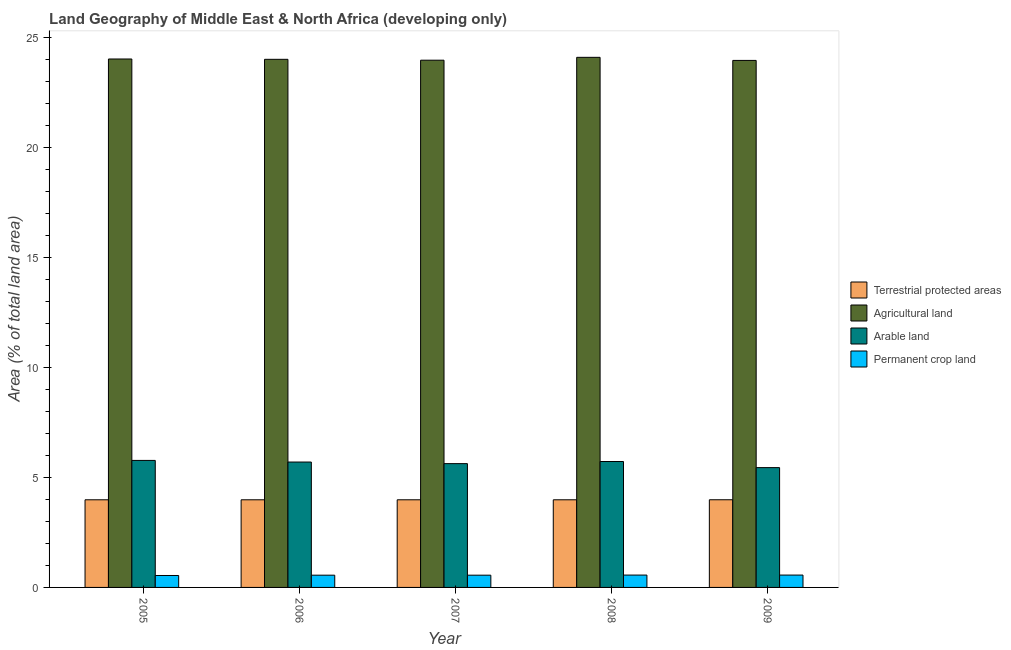How many different coloured bars are there?
Offer a very short reply. 4. What is the percentage of area under arable land in 2006?
Your answer should be compact. 5.7. Across all years, what is the maximum percentage of land under terrestrial protection?
Provide a succinct answer. 3.98. Across all years, what is the minimum percentage of area under permanent crop land?
Offer a very short reply. 0.54. In which year was the percentage of area under agricultural land minimum?
Ensure brevity in your answer.  2009. What is the total percentage of land under terrestrial protection in the graph?
Provide a succinct answer. 19.92. What is the difference between the percentage of area under permanent crop land in 2006 and that in 2008?
Make the answer very short. -0.01. What is the difference between the percentage of area under arable land in 2008 and the percentage of land under terrestrial protection in 2009?
Offer a terse response. 0.28. What is the average percentage of area under permanent crop land per year?
Your answer should be compact. 0.56. In the year 2006, what is the difference between the percentage of area under agricultural land and percentage of area under permanent crop land?
Ensure brevity in your answer.  0. In how many years, is the percentage of area under arable land greater than 20 %?
Ensure brevity in your answer.  0. What is the ratio of the percentage of area under arable land in 2006 to that in 2009?
Your answer should be compact. 1.05. Is the percentage of area under permanent crop land in 2005 less than that in 2009?
Your response must be concise. Yes. What is the difference between the highest and the second highest percentage of area under agricultural land?
Your answer should be compact. 0.08. What is the difference between the highest and the lowest percentage of area under agricultural land?
Provide a succinct answer. 0.14. Is the sum of the percentage of area under arable land in 2006 and 2008 greater than the maximum percentage of area under permanent crop land across all years?
Offer a very short reply. Yes. Is it the case that in every year, the sum of the percentage of area under agricultural land and percentage of land under terrestrial protection is greater than the sum of percentage of area under permanent crop land and percentage of area under arable land?
Your answer should be very brief. Yes. What does the 4th bar from the left in 2006 represents?
Your answer should be compact. Permanent crop land. What does the 1st bar from the right in 2007 represents?
Provide a short and direct response. Permanent crop land. Is it the case that in every year, the sum of the percentage of land under terrestrial protection and percentage of area under agricultural land is greater than the percentage of area under arable land?
Keep it short and to the point. Yes. What is the difference between two consecutive major ticks on the Y-axis?
Give a very brief answer. 5. Are the values on the major ticks of Y-axis written in scientific E-notation?
Your answer should be very brief. No. Does the graph contain any zero values?
Give a very brief answer. No. Does the graph contain grids?
Offer a terse response. No. How are the legend labels stacked?
Ensure brevity in your answer.  Vertical. What is the title of the graph?
Keep it short and to the point. Land Geography of Middle East & North Africa (developing only). Does "Denmark" appear as one of the legend labels in the graph?
Give a very brief answer. No. What is the label or title of the X-axis?
Give a very brief answer. Year. What is the label or title of the Y-axis?
Make the answer very short. Area (% of total land area). What is the Area (% of total land area) of Terrestrial protected areas in 2005?
Your answer should be compact. 3.98. What is the Area (% of total land area) in Agricultural land in 2005?
Give a very brief answer. 24.02. What is the Area (% of total land area) in Arable land in 2005?
Your answer should be compact. 5.77. What is the Area (% of total land area) in Permanent crop land in 2005?
Ensure brevity in your answer.  0.54. What is the Area (% of total land area) of Terrestrial protected areas in 2006?
Keep it short and to the point. 3.98. What is the Area (% of total land area) in Agricultural land in 2006?
Your response must be concise. 24.01. What is the Area (% of total land area) of Arable land in 2006?
Offer a terse response. 5.7. What is the Area (% of total land area) in Permanent crop land in 2006?
Your answer should be compact. 0.56. What is the Area (% of total land area) of Terrestrial protected areas in 2007?
Your answer should be compact. 3.98. What is the Area (% of total land area) of Agricultural land in 2007?
Provide a succinct answer. 23.97. What is the Area (% of total land area) in Arable land in 2007?
Your answer should be compact. 5.63. What is the Area (% of total land area) in Permanent crop land in 2007?
Your response must be concise. 0.56. What is the Area (% of total land area) of Terrestrial protected areas in 2008?
Ensure brevity in your answer.  3.98. What is the Area (% of total land area) in Agricultural land in 2008?
Offer a terse response. 24.1. What is the Area (% of total land area) of Arable land in 2008?
Make the answer very short. 5.72. What is the Area (% of total land area) in Permanent crop land in 2008?
Your answer should be very brief. 0.56. What is the Area (% of total land area) of Terrestrial protected areas in 2009?
Provide a succinct answer. 3.98. What is the Area (% of total land area) of Agricultural land in 2009?
Give a very brief answer. 23.96. What is the Area (% of total land area) in Arable land in 2009?
Give a very brief answer. 5.45. What is the Area (% of total land area) of Permanent crop land in 2009?
Make the answer very short. 0.56. Across all years, what is the maximum Area (% of total land area) of Terrestrial protected areas?
Provide a short and direct response. 3.98. Across all years, what is the maximum Area (% of total land area) in Agricultural land?
Offer a very short reply. 24.1. Across all years, what is the maximum Area (% of total land area) of Arable land?
Your response must be concise. 5.77. Across all years, what is the maximum Area (% of total land area) of Permanent crop land?
Provide a short and direct response. 0.56. Across all years, what is the minimum Area (% of total land area) of Terrestrial protected areas?
Your response must be concise. 3.98. Across all years, what is the minimum Area (% of total land area) of Agricultural land?
Make the answer very short. 23.96. Across all years, what is the minimum Area (% of total land area) in Arable land?
Offer a very short reply. 5.45. Across all years, what is the minimum Area (% of total land area) in Permanent crop land?
Offer a terse response. 0.54. What is the total Area (% of total land area) of Terrestrial protected areas in the graph?
Your response must be concise. 19.92. What is the total Area (% of total land area) of Agricultural land in the graph?
Provide a succinct answer. 120.04. What is the total Area (% of total land area) of Arable land in the graph?
Keep it short and to the point. 28.27. What is the total Area (% of total land area) in Permanent crop land in the graph?
Ensure brevity in your answer.  2.78. What is the difference between the Area (% of total land area) of Agricultural land in 2005 and that in 2006?
Your answer should be very brief. 0.02. What is the difference between the Area (% of total land area) in Arable land in 2005 and that in 2006?
Provide a short and direct response. 0.07. What is the difference between the Area (% of total land area) in Permanent crop land in 2005 and that in 2006?
Ensure brevity in your answer.  -0.01. What is the difference between the Area (% of total land area) of Terrestrial protected areas in 2005 and that in 2007?
Your response must be concise. 0. What is the difference between the Area (% of total land area) of Agricultural land in 2005 and that in 2007?
Provide a succinct answer. 0.06. What is the difference between the Area (% of total land area) in Arable land in 2005 and that in 2007?
Keep it short and to the point. 0.15. What is the difference between the Area (% of total land area) of Permanent crop land in 2005 and that in 2007?
Offer a very short reply. -0.01. What is the difference between the Area (% of total land area) of Agricultural land in 2005 and that in 2008?
Your answer should be very brief. -0.08. What is the difference between the Area (% of total land area) in Arable land in 2005 and that in 2008?
Offer a terse response. 0.05. What is the difference between the Area (% of total land area) in Permanent crop land in 2005 and that in 2008?
Make the answer very short. -0.02. What is the difference between the Area (% of total land area) of Terrestrial protected areas in 2005 and that in 2009?
Provide a short and direct response. -0. What is the difference between the Area (% of total land area) in Agricultural land in 2005 and that in 2009?
Offer a very short reply. 0.07. What is the difference between the Area (% of total land area) of Arable land in 2005 and that in 2009?
Keep it short and to the point. 0.33. What is the difference between the Area (% of total land area) of Permanent crop land in 2005 and that in 2009?
Provide a short and direct response. -0.02. What is the difference between the Area (% of total land area) in Agricultural land in 2006 and that in 2007?
Ensure brevity in your answer.  0.04. What is the difference between the Area (% of total land area) of Arable land in 2006 and that in 2007?
Your response must be concise. 0.07. What is the difference between the Area (% of total land area) in Permanent crop land in 2006 and that in 2007?
Offer a terse response. -0. What is the difference between the Area (% of total land area) of Terrestrial protected areas in 2006 and that in 2008?
Your answer should be compact. 0. What is the difference between the Area (% of total land area) in Agricultural land in 2006 and that in 2008?
Your response must be concise. -0.09. What is the difference between the Area (% of total land area) of Arable land in 2006 and that in 2008?
Offer a terse response. -0.02. What is the difference between the Area (% of total land area) in Permanent crop land in 2006 and that in 2008?
Your answer should be very brief. -0.01. What is the difference between the Area (% of total land area) in Terrestrial protected areas in 2006 and that in 2009?
Provide a succinct answer. -0. What is the difference between the Area (% of total land area) of Agricultural land in 2006 and that in 2009?
Provide a short and direct response. 0.05. What is the difference between the Area (% of total land area) in Arable land in 2006 and that in 2009?
Your response must be concise. 0.25. What is the difference between the Area (% of total land area) of Permanent crop land in 2006 and that in 2009?
Make the answer very short. -0.01. What is the difference between the Area (% of total land area) in Terrestrial protected areas in 2007 and that in 2008?
Keep it short and to the point. 0. What is the difference between the Area (% of total land area) in Agricultural land in 2007 and that in 2008?
Make the answer very short. -0.13. What is the difference between the Area (% of total land area) of Arable land in 2007 and that in 2008?
Your response must be concise. -0.1. What is the difference between the Area (% of total land area) in Permanent crop land in 2007 and that in 2008?
Offer a very short reply. -0. What is the difference between the Area (% of total land area) in Terrestrial protected areas in 2007 and that in 2009?
Your response must be concise. -0. What is the difference between the Area (% of total land area) of Agricultural land in 2007 and that in 2009?
Make the answer very short. 0.01. What is the difference between the Area (% of total land area) of Arable land in 2007 and that in 2009?
Give a very brief answer. 0.18. What is the difference between the Area (% of total land area) of Permanent crop land in 2007 and that in 2009?
Your answer should be compact. -0.01. What is the difference between the Area (% of total land area) in Terrestrial protected areas in 2008 and that in 2009?
Give a very brief answer. -0. What is the difference between the Area (% of total land area) in Agricultural land in 2008 and that in 2009?
Make the answer very short. 0.14. What is the difference between the Area (% of total land area) in Arable land in 2008 and that in 2009?
Provide a short and direct response. 0.28. What is the difference between the Area (% of total land area) of Permanent crop land in 2008 and that in 2009?
Provide a succinct answer. -0. What is the difference between the Area (% of total land area) of Terrestrial protected areas in 2005 and the Area (% of total land area) of Agricultural land in 2006?
Offer a very short reply. -20.02. What is the difference between the Area (% of total land area) of Terrestrial protected areas in 2005 and the Area (% of total land area) of Arable land in 2006?
Offer a very short reply. -1.72. What is the difference between the Area (% of total land area) in Terrestrial protected areas in 2005 and the Area (% of total land area) in Permanent crop land in 2006?
Provide a short and direct response. 3.43. What is the difference between the Area (% of total land area) in Agricultural land in 2005 and the Area (% of total land area) in Arable land in 2006?
Make the answer very short. 18.32. What is the difference between the Area (% of total land area) in Agricultural land in 2005 and the Area (% of total land area) in Permanent crop land in 2006?
Your answer should be very brief. 23.46. What is the difference between the Area (% of total land area) in Arable land in 2005 and the Area (% of total land area) in Permanent crop land in 2006?
Make the answer very short. 5.22. What is the difference between the Area (% of total land area) in Terrestrial protected areas in 2005 and the Area (% of total land area) in Agricultural land in 2007?
Provide a short and direct response. -19.98. What is the difference between the Area (% of total land area) in Terrestrial protected areas in 2005 and the Area (% of total land area) in Arable land in 2007?
Your answer should be compact. -1.64. What is the difference between the Area (% of total land area) in Terrestrial protected areas in 2005 and the Area (% of total land area) in Permanent crop land in 2007?
Give a very brief answer. 3.43. What is the difference between the Area (% of total land area) of Agricultural land in 2005 and the Area (% of total land area) of Arable land in 2007?
Keep it short and to the point. 18.39. What is the difference between the Area (% of total land area) in Agricultural land in 2005 and the Area (% of total land area) in Permanent crop land in 2007?
Provide a succinct answer. 23.46. What is the difference between the Area (% of total land area) in Arable land in 2005 and the Area (% of total land area) in Permanent crop land in 2007?
Offer a terse response. 5.22. What is the difference between the Area (% of total land area) in Terrestrial protected areas in 2005 and the Area (% of total land area) in Agricultural land in 2008?
Ensure brevity in your answer.  -20.11. What is the difference between the Area (% of total land area) of Terrestrial protected areas in 2005 and the Area (% of total land area) of Arable land in 2008?
Your answer should be very brief. -1.74. What is the difference between the Area (% of total land area) of Terrestrial protected areas in 2005 and the Area (% of total land area) of Permanent crop land in 2008?
Make the answer very short. 3.42. What is the difference between the Area (% of total land area) in Agricultural land in 2005 and the Area (% of total land area) in Arable land in 2008?
Keep it short and to the point. 18.3. What is the difference between the Area (% of total land area) of Agricultural land in 2005 and the Area (% of total land area) of Permanent crop land in 2008?
Provide a short and direct response. 23.46. What is the difference between the Area (% of total land area) of Arable land in 2005 and the Area (% of total land area) of Permanent crop land in 2008?
Keep it short and to the point. 5.21. What is the difference between the Area (% of total land area) in Terrestrial protected areas in 2005 and the Area (% of total land area) in Agricultural land in 2009?
Provide a short and direct response. -19.97. What is the difference between the Area (% of total land area) of Terrestrial protected areas in 2005 and the Area (% of total land area) of Arable land in 2009?
Keep it short and to the point. -1.46. What is the difference between the Area (% of total land area) in Terrestrial protected areas in 2005 and the Area (% of total land area) in Permanent crop land in 2009?
Provide a short and direct response. 3.42. What is the difference between the Area (% of total land area) in Agricultural land in 2005 and the Area (% of total land area) in Arable land in 2009?
Give a very brief answer. 18.57. What is the difference between the Area (% of total land area) of Agricultural land in 2005 and the Area (% of total land area) of Permanent crop land in 2009?
Your answer should be very brief. 23.46. What is the difference between the Area (% of total land area) in Arable land in 2005 and the Area (% of total land area) in Permanent crop land in 2009?
Provide a short and direct response. 5.21. What is the difference between the Area (% of total land area) of Terrestrial protected areas in 2006 and the Area (% of total land area) of Agricultural land in 2007?
Your answer should be very brief. -19.98. What is the difference between the Area (% of total land area) of Terrestrial protected areas in 2006 and the Area (% of total land area) of Arable land in 2007?
Offer a terse response. -1.64. What is the difference between the Area (% of total land area) in Terrestrial protected areas in 2006 and the Area (% of total land area) in Permanent crop land in 2007?
Ensure brevity in your answer.  3.43. What is the difference between the Area (% of total land area) in Agricultural land in 2006 and the Area (% of total land area) in Arable land in 2007?
Keep it short and to the point. 18.38. What is the difference between the Area (% of total land area) in Agricultural land in 2006 and the Area (% of total land area) in Permanent crop land in 2007?
Make the answer very short. 23.45. What is the difference between the Area (% of total land area) of Arable land in 2006 and the Area (% of total land area) of Permanent crop land in 2007?
Your answer should be very brief. 5.14. What is the difference between the Area (% of total land area) of Terrestrial protected areas in 2006 and the Area (% of total land area) of Agricultural land in 2008?
Offer a terse response. -20.11. What is the difference between the Area (% of total land area) in Terrestrial protected areas in 2006 and the Area (% of total land area) in Arable land in 2008?
Give a very brief answer. -1.74. What is the difference between the Area (% of total land area) in Terrestrial protected areas in 2006 and the Area (% of total land area) in Permanent crop land in 2008?
Your response must be concise. 3.42. What is the difference between the Area (% of total land area) of Agricultural land in 2006 and the Area (% of total land area) of Arable land in 2008?
Make the answer very short. 18.28. What is the difference between the Area (% of total land area) in Agricultural land in 2006 and the Area (% of total land area) in Permanent crop land in 2008?
Offer a terse response. 23.44. What is the difference between the Area (% of total land area) of Arable land in 2006 and the Area (% of total land area) of Permanent crop land in 2008?
Provide a succinct answer. 5.14. What is the difference between the Area (% of total land area) in Terrestrial protected areas in 2006 and the Area (% of total land area) in Agricultural land in 2009?
Offer a terse response. -19.97. What is the difference between the Area (% of total land area) of Terrestrial protected areas in 2006 and the Area (% of total land area) of Arable land in 2009?
Provide a succinct answer. -1.46. What is the difference between the Area (% of total land area) of Terrestrial protected areas in 2006 and the Area (% of total land area) of Permanent crop land in 2009?
Ensure brevity in your answer.  3.42. What is the difference between the Area (% of total land area) of Agricultural land in 2006 and the Area (% of total land area) of Arable land in 2009?
Ensure brevity in your answer.  18.56. What is the difference between the Area (% of total land area) of Agricultural land in 2006 and the Area (% of total land area) of Permanent crop land in 2009?
Make the answer very short. 23.44. What is the difference between the Area (% of total land area) in Arable land in 2006 and the Area (% of total land area) in Permanent crop land in 2009?
Offer a very short reply. 5.14. What is the difference between the Area (% of total land area) in Terrestrial protected areas in 2007 and the Area (% of total land area) in Agricultural land in 2008?
Offer a terse response. -20.11. What is the difference between the Area (% of total land area) of Terrestrial protected areas in 2007 and the Area (% of total land area) of Arable land in 2008?
Your answer should be very brief. -1.74. What is the difference between the Area (% of total land area) in Terrestrial protected areas in 2007 and the Area (% of total land area) in Permanent crop land in 2008?
Give a very brief answer. 3.42. What is the difference between the Area (% of total land area) in Agricultural land in 2007 and the Area (% of total land area) in Arable land in 2008?
Make the answer very short. 18.24. What is the difference between the Area (% of total land area) in Agricultural land in 2007 and the Area (% of total land area) in Permanent crop land in 2008?
Provide a succinct answer. 23.4. What is the difference between the Area (% of total land area) in Arable land in 2007 and the Area (% of total land area) in Permanent crop land in 2008?
Give a very brief answer. 5.07. What is the difference between the Area (% of total land area) of Terrestrial protected areas in 2007 and the Area (% of total land area) of Agricultural land in 2009?
Give a very brief answer. -19.97. What is the difference between the Area (% of total land area) of Terrestrial protected areas in 2007 and the Area (% of total land area) of Arable land in 2009?
Your answer should be very brief. -1.46. What is the difference between the Area (% of total land area) in Terrestrial protected areas in 2007 and the Area (% of total land area) in Permanent crop land in 2009?
Your response must be concise. 3.42. What is the difference between the Area (% of total land area) in Agricultural land in 2007 and the Area (% of total land area) in Arable land in 2009?
Offer a very short reply. 18.52. What is the difference between the Area (% of total land area) of Agricultural land in 2007 and the Area (% of total land area) of Permanent crop land in 2009?
Your answer should be very brief. 23.4. What is the difference between the Area (% of total land area) in Arable land in 2007 and the Area (% of total land area) in Permanent crop land in 2009?
Provide a short and direct response. 5.07. What is the difference between the Area (% of total land area) of Terrestrial protected areas in 2008 and the Area (% of total land area) of Agricultural land in 2009?
Keep it short and to the point. -19.97. What is the difference between the Area (% of total land area) in Terrestrial protected areas in 2008 and the Area (% of total land area) in Arable land in 2009?
Keep it short and to the point. -1.46. What is the difference between the Area (% of total land area) in Terrestrial protected areas in 2008 and the Area (% of total land area) in Permanent crop land in 2009?
Offer a terse response. 3.42. What is the difference between the Area (% of total land area) of Agricultural land in 2008 and the Area (% of total land area) of Arable land in 2009?
Keep it short and to the point. 18.65. What is the difference between the Area (% of total land area) in Agricultural land in 2008 and the Area (% of total land area) in Permanent crop land in 2009?
Offer a terse response. 23.53. What is the difference between the Area (% of total land area) in Arable land in 2008 and the Area (% of total land area) in Permanent crop land in 2009?
Offer a terse response. 5.16. What is the average Area (% of total land area) in Terrestrial protected areas per year?
Provide a short and direct response. 3.98. What is the average Area (% of total land area) in Agricultural land per year?
Provide a short and direct response. 24.01. What is the average Area (% of total land area) in Arable land per year?
Your answer should be very brief. 5.65. What is the average Area (% of total land area) in Permanent crop land per year?
Provide a succinct answer. 0.56. In the year 2005, what is the difference between the Area (% of total land area) in Terrestrial protected areas and Area (% of total land area) in Agricultural land?
Your answer should be very brief. -20.04. In the year 2005, what is the difference between the Area (% of total land area) in Terrestrial protected areas and Area (% of total land area) in Arable land?
Your response must be concise. -1.79. In the year 2005, what is the difference between the Area (% of total land area) in Terrestrial protected areas and Area (% of total land area) in Permanent crop land?
Offer a terse response. 3.44. In the year 2005, what is the difference between the Area (% of total land area) in Agricultural land and Area (% of total land area) in Arable land?
Give a very brief answer. 18.25. In the year 2005, what is the difference between the Area (% of total land area) in Agricultural land and Area (% of total land area) in Permanent crop land?
Ensure brevity in your answer.  23.48. In the year 2005, what is the difference between the Area (% of total land area) of Arable land and Area (% of total land area) of Permanent crop land?
Provide a succinct answer. 5.23. In the year 2006, what is the difference between the Area (% of total land area) in Terrestrial protected areas and Area (% of total land area) in Agricultural land?
Offer a terse response. -20.02. In the year 2006, what is the difference between the Area (% of total land area) in Terrestrial protected areas and Area (% of total land area) in Arable land?
Your answer should be compact. -1.72. In the year 2006, what is the difference between the Area (% of total land area) of Terrestrial protected areas and Area (% of total land area) of Permanent crop land?
Ensure brevity in your answer.  3.43. In the year 2006, what is the difference between the Area (% of total land area) in Agricultural land and Area (% of total land area) in Arable land?
Keep it short and to the point. 18.31. In the year 2006, what is the difference between the Area (% of total land area) in Agricultural land and Area (% of total land area) in Permanent crop land?
Provide a succinct answer. 23.45. In the year 2006, what is the difference between the Area (% of total land area) of Arable land and Area (% of total land area) of Permanent crop land?
Offer a very short reply. 5.14. In the year 2007, what is the difference between the Area (% of total land area) in Terrestrial protected areas and Area (% of total land area) in Agricultural land?
Offer a terse response. -19.98. In the year 2007, what is the difference between the Area (% of total land area) in Terrestrial protected areas and Area (% of total land area) in Arable land?
Offer a very short reply. -1.64. In the year 2007, what is the difference between the Area (% of total land area) of Terrestrial protected areas and Area (% of total land area) of Permanent crop land?
Offer a very short reply. 3.43. In the year 2007, what is the difference between the Area (% of total land area) in Agricultural land and Area (% of total land area) in Arable land?
Provide a succinct answer. 18.34. In the year 2007, what is the difference between the Area (% of total land area) in Agricultural land and Area (% of total land area) in Permanent crop land?
Provide a short and direct response. 23.41. In the year 2007, what is the difference between the Area (% of total land area) in Arable land and Area (% of total land area) in Permanent crop land?
Offer a very short reply. 5.07. In the year 2008, what is the difference between the Area (% of total land area) in Terrestrial protected areas and Area (% of total land area) in Agricultural land?
Provide a short and direct response. -20.11. In the year 2008, what is the difference between the Area (% of total land area) in Terrestrial protected areas and Area (% of total land area) in Arable land?
Keep it short and to the point. -1.74. In the year 2008, what is the difference between the Area (% of total land area) of Terrestrial protected areas and Area (% of total land area) of Permanent crop land?
Give a very brief answer. 3.42. In the year 2008, what is the difference between the Area (% of total land area) in Agricultural land and Area (% of total land area) in Arable land?
Make the answer very short. 18.37. In the year 2008, what is the difference between the Area (% of total land area) of Agricultural land and Area (% of total land area) of Permanent crop land?
Make the answer very short. 23.53. In the year 2008, what is the difference between the Area (% of total land area) in Arable land and Area (% of total land area) in Permanent crop land?
Offer a terse response. 5.16. In the year 2009, what is the difference between the Area (% of total land area) in Terrestrial protected areas and Area (% of total land area) in Agricultural land?
Keep it short and to the point. -19.97. In the year 2009, what is the difference between the Area (% of total land area) in Terrestrial protected areas and Area (% of total land area) in Arable land?
Make the answer very short. -1.46. In the year 2009, what is the difference between the Area (% of total land area) in Terrestrial protected areas and Area (% of total land area) in Permanent crop land?
Your answer should be compact. 3.42. In the year 2009, what is the difference between the Area (% of total land area) of Agricultural land and Area (% of total land area) of Arable land?
Keep it short and to the point. 18.51. In the year 2009, what is the difference between the Area (% of total land area) in Agricultural land and Area (% of total land area) in Permanent crop land?
Your answer should be very brief. 23.39. In the year 2009, what is the difference between the Area (% of total land area) in Arable land and Area (% of total land area) in Permanent crop land?
Ensure brevity in your answer.  4.88. What is the ratio of the Area (% of total land area) in Terrestrial protected areas in 2005 to that in 2006?
Your answer should be compact. 1. What is the ratio of the Area (% of total land area) of Agricultural land in 2005 to that in 2006?
Give a very brief answer. 1. What is the ratio of the Area (% of total land area) of Permanent crop land in 2005 to that in 2006?
Provide a short and direct response. 0.97. What is the ratio of the Area (% of total land area) of Terrestrial protected areas in 2005 to that in 2007?
Give a very brief answer. 1. What is the ratio of the Area (% of total land area) of Agricultural land in 2005 to that in 2007?
Your answer should be compact. 1. What is the ratio of the Area (% of total land area) in Permanent crop land in 2005 to that in 2007?
Your answer should be very brief. 0.97. What is the ratio of the Area (% of total land area) in Agricultural land in 2005 to that in 2008?
Give a very brief answer. 1. What is the ratio of the Area (% of total land area) in Arable land in 2005 to that in 2008?
Your answer should be compact. 1.01. What is the ratio of the Area (% of total land area) of Permanent crop land in 2005 to that in 2008?
Provide a succinct answer. 0.97. What is the ratio of the Area (% of total land area) of Arable land in 2005 to that in 2009?
Ensure brevity in your answer.  1.06. What is the ratio of the Area (% of total land area) in Permanent crop land in 2005 to that in 2009?
Provide a short and direct response. 0.97. What is the ratio of the Area (% of total land area) of Terrestrial protected areas in 2006 to that in 2007?
Make the answer very short. 1. What is the ratio of the Area (% of total land area) in Agricultural land in 2006 to that in 2007?
Ensure brevity in your answer.  1. What is the ratio of the Area (% of total land area) of Arable land in 2006 to that in 2007?
Make the answer very short. 1.01. What is the ratio of the Area (% of total land area) in Terrestrial protected areas in 2006 to that in 2008?
Your answer should be compact. 1. What is the ratio of the Area (% of total land area) in Agricultural land in 2006 to that in 2008?
Your answer should be very brief. 1. What is the ratio of the Area (% of total land area) in Arable land in 2006 to that in 2008?
Provide a succinct answer. 1. What is the ratio of the Area (% of total land area) in Permanent crop land in 2006 to that in 2008?
Keep it short and to the point. 0.99. What is the ratio of the Area (% of total land area) of Terrestrial protected areas in 2006 to that in 2009?
Offer a terse response. 1. What is the ratio of the Area (% of total land area) in Agricultural land in 2006 to that in 2009?
Keep it short and to the point. 1. What is the ratio of the Area (% of total land area) in Arable land in 2006 to that in 2009?
Keep it short and to the point. 1.05. What is the ratio of the Area (% of total land area) of Permanent crop land in 2006 to that in 2009?
Provide a short and direct response. 0.99. What is the ratio of the Area (% of total land area) of Terrestrial protected areas in 2007 to that in 2008?
Offer a terse response. 1. What is the ratio of the Area (% of total land area) of Arable land in 2007 to that in 2008?
Offer a very short reply. 0.98. What is the ratio of the Area (% of total land area) in Permanent crop land in 2007 to that in 2008?
Provide a short and direct response. 0.99. What is the ratio of the Area (% of total land area) in Terrestrial protected areas in 2007 to that in 2009?
Offer a terse response. 1. What is the ratio of the Area (% of total land area) of Agricultural land in 2007 to that in 2009?
Your answer should be very brief. 1. What is the ratio of the Area (% of total land area) of Arable land in 2007 to that in 2009?
Ensure brevity in your answer.  1.03. What is the ratio of the Area (% of total land area) of Permanent crop land in 2007 to that in 2009?
Your answer should be compact. 0.99. What is the ratio of the Area (% of total land area) in Terrestrial protected areas in 2008 to that in 2009?
Provide a short and direct response. 1. What is the ratio of the Area (% of total land area) in Agricultural land in 2008 to that in 2009?
Provide a short and direct response. 1.01. What is the ratio of the Area (% of total land area) of Arable land in 2008 to that in 2009?
Provide a short and direct response. 1.05. What is the difference between the highest and the second highest Area (% of total land area) of Terrestrial protected areas?
Provide a short and direct response. 0. What is the difference between the highest and the second highest Area (% of total land area) in Agricultural land?
Offer a very short reply. 0.08. What is the difference between the highest and the lowest Area (% of total land area) in Terrestrial protected areas?
Offer a very short reply. 0. What is the difference between the highest and the lowest Area (% of total land area) in Agricultural land?
Keep it short and to the point. 0.14. What is the difference between the highest and the lowest Area (% of total land area) of Arable land?
Give a very brief answer. 0.33. What is the difference between the highest and the lowest Area (% of total land area) of Permanent crop land?
Your response must be concise. 0.02. 